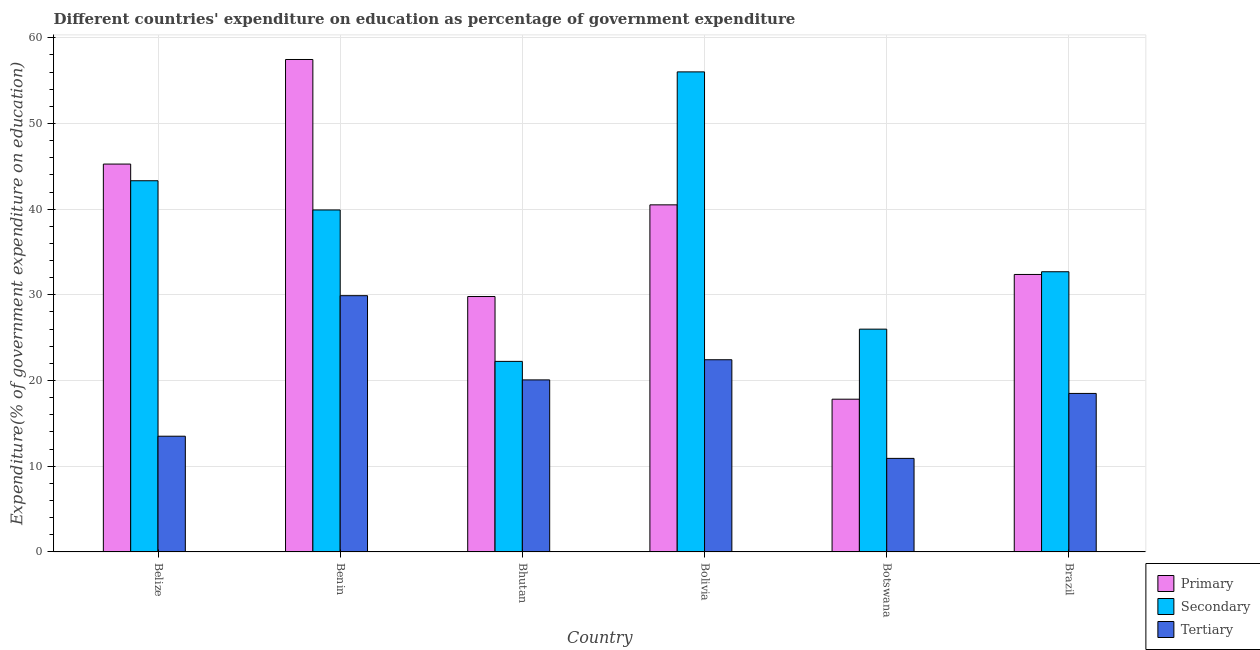How many groups of bars are there?
Offer a terse response. 6. Are the number of bars per tick equal to the number of legend labels?
Offer a terse response. Yes. Are the number of bars on each tick of the X-axis equal?
Your response must be concise. Yes. How many bars are there on the 6th tick from the left?
Ensure brevity in your answer.  3. How many bars are there on the 6th tick from the right?
Your answer should be very brief. 3. What is the label of the 1st group of bars from the left?
Give a very brief answer. Belize. In how many cases, is the number of bars for a given country not equal to the number of legend labels?
Provide a succinct answer. 0. What is the expenditure on primary education in Bhutan?
Give a very brief answer. 29.8. Across all countries, what is the maximum expenditure on tertiary education?
Your response must be concise. 29.9. Across all countries, what is the minimum expenditure on secondary education?
Make the answer very short. 22.23. In which country was the expenditure on tertiary education maximum?
Offer a very short reply. Benin. In which country was the expenditure on secondary education minimum?
Your answer should be very brief. Bhutan. What is the total expenditure on primary education in the graph?
Provide a short and direct response. 223.23. What is the difference between the expenditure on primary education in Bhutan and that in Bolivia?
Give a very brief answer. -10.7. What is the difference between the expenditure on primary education in Brazil and the expenditure on tertiary education in Botswana?
Your response must be concise. 21.46. What is the average expenditure on tertiary education per country?
Make the answer very short. 19.22. What is the difference between the expenditure on primary education and expenditure on secondary education in Belize?
Your response must be concise. 1.95. In how many countries, is the expenditure on secondary education greater than 2 %?
Give a very brief answer. 6. What is the ratio of the expenditure on tertiary education in Belize to that in Benin?
Keep it short and to the point. 0.45. Is the difference between the expenditure on tertiary education in Benin and Bolivia greater than the difference between the expenditure on secondary education in Benin and Bolivia?
Keep it short and to the point. Yes. What is the difference between the highest and the second highest expenditure on primary education?
Give a very brief answer. 12.2. What is the difference between the highest and the lowest expenditure on tertiary education?
Your answer should be compact. 18.99. In how many countries, is the expenditure on tertiary education greater than the average expenditure on tertiary education taken over all countries?
Provide a short and direct response. 3. What does the 2nd bar from the left in Bolivia represents?
Ensure brevity in your answer.  Secondary. What does the 1st bar from the right in Bolivia represents?
Offer a terse response. Tertiary. Is it the case that in every country, the sum of the expenditure on primary education and expenditure on secondary education is greater than the expenditure on tertiary education?
Ensure brevity in your answer.  Yes. How many bars are there?
Ensure brevity in your answer.  18. Are all the bars in the graph horizontal?
Offer a very short reply. No. What is the difference between two consecutive major ticks on the Y-axis?
Ensure brevity in your answer.  10. Does the graph contain grids?
Your response must be concise. Yes. How many legend labels are there?
Keep it short and to the point. 3. What is the title of the graph?
Make the answer very short. Different countries' expenditure on education as percentage of government expenditure. Does "Ages 20-50" appear as one of the legend labels in the graph?
Keep it short and to the point. No. What is the label or title of the X-axis?
Provide a short and direct response. Country. What is the label or title of the Y-axis?
Your answer should be compact. Expenditure(% of government expenditure on education). What is the Expenditure(% of government expenditure on education) of Primary in Belize?
Give a very brief answer. 45.26. What is the Expenditure(% of government expenditure on education) of Secondary in Belize?
Ensure brevity in your answer.  43.32. What is the Expenditure(% of government expenditure on education) of Tertiary in Belize?
Your answer should be very brief. 13.5. What is the Expenditure(% of government expenditure on education) in Primary in Benin?
Keep it short and to the point. 57.47. What is the Expenditure(% of government expenditure on education) in Secondary in Benin?
Keep it short and to the point. 39.91. What is the Expenditure(% of government expenditure on education) in Tertiary in Benin?
Your answer should be compact. 29.9. What is the Expenditure(% of government expenditure on education) of Primary in Bhutan?
Offer a very short reply. 29.8. What is the Expenditure(% of government expenditure on education) of Secondary in Bhutan?
Your answer should be compact. 22.23. What is the Expenditure(% of government expenditure on education) in Tertiary in Bhutan?
Keep it short and to the point. 20.07. What is the Expenditure(% of government expenditure on education) in Primary in Bolivia?
Give a very brief answer. 40.5. What is the Expenditure(% of government expenditure on education) of Secondary in Bolivia?
Keep it short and to the point. 56.02. What is the Expenditure(% of government expenditure on education) of Tertiary in Bolivia?
Make the answer very short. 22.43. What is the Expenditure(% of government expenditure on education) of Primary in Botswana?
Keep it short and to the point. 17.82. What is the Expenditure(% of government expenditure on education) of Secondary in Botswana?
Offer a very short reply. 26. What is the Expenditure(% of government expenditure on education) in Tertiary in Botswana?
Provide a succinct answer. 10.91. What is the Expenditure(% of government expenditure on education) in Primary in Brazil?
Offer a very short reply. 32.38. What is the Expenditure(% of government expenditure on education) of Secondary in Brazil?
Your response must be concise. 32.7. What is the Expenditure(% of government expenditure on education) in Tertiary in Brazil?
Offer a very short reply. 18.5. Across all countries, what is the maximum Expenditure(% of government expenditure on education) of Primary?
Ensure brevity in your answer.  57.47. Across all countries, what is the maximum Expenditure(% of government expenditure on education) in Secondary?
Offer a terse response. 56.02. Across all countries, what is the maximum Expenditure(% of government expenditure on education) of Tertiary?
Keep it short and to the point. 29.9. Across all countries, what is the minimum Expenditure(% of government expenditure on education) of Primary?
Offer a terse response. 17.82. Across all countries, what is the minimum Expenditure(% of government expenditure on education) of Secondary?
Keep it short and to the point. 22.23. Across all countries, what is the minimum Expenditure(% of government expenditure on education) in Tertiary?
Make the answer very short. 10.91. What is the total Expenditure(% of government expenditure on education) in Primary in the graph?
Provide a succinct answer. 223.23. What is the total Expenditure(% of government expenditure on education) of Secondary in the graph?
Your answer should be very brief. 220.17. What is the total Expenditure(% of government expenditure on education) in Tertiary in the graph?
Provide a succinct answer. 115.31. What is the difference between the Expenditure(% of government expenditure on education) in Primary in Belize and that in Benin?
Keep it short and to the point. -12.2. What is the difference between the Expenditure(% of government expenditure on education) in Secondary in Belize and that in Benin?
Offer a terse response. 3.41. What is the difference between the Expenditure(% of government expenditure on education) of Tertiary in Belize and that in Benin?
Give a very brief answer. -16.4. What is the difference between the Expenditure(% of government expenditure on education) in Primary in Belize and that in Bhutan?
Your answer should be compact. 15.46. What is the difference between the Expenditure(% of government expenditure on education) in Secondary in Belize and that in Bhutan?
Provide a short and direct response. 21.08. What is the difference between the Expenditure(% of government expenditure on education) in Tertiary in Belize and that in Bhutan?
Give a very brief answer. -6.57. What is the difference between the Expenditure(% of government expenditure on education) in Primary in Belize and that in Bolivia?
Your answer should be compact. 4.76. What is the difference between the Expenditure(% of government expenditure on education) in Secondary in Belize and that in Bolivia?
Provide a short and direct response. -12.7. What is the difference between the Expenditure(% of government expenditure on education) of Tertiary in Belize and that in Bolivia?
Make the answer very short. -8.92. What is the difference between the Expenditure(% of government expenditure on education) in Primary in Belize and that in Botswana?
Your response must be concise. 27.44. What is the difference between the Expenditure(% of government expenditure on education) of Secondary in Belize and that in Botswana?
Offer a very short reply. 17.32. What is the difference between the Expenditure(% of government expenditure on education) in Tertiary in Belize and that in Botswana?
Provide a short and direct response. 2.59. What is the difference between the Expenditure(% of government expenditure on education) in Primary in Belize and that in Brazil?
Give a very brief answer. 12.88. What is the difference between the Expenditure(% of government expenditure on education) of Secondary in Belize and that in Brazil?
Your answer should be very brief. 10.62. What is the difference between the Expenditure(% of government expenditure on education) of Tertiary in Belize and that in Brazil?
Offer a terse response. -4.99. What is the difference between the Expenditure(% of government expenditure on education) of Primary in Benin and that in Bhutan?
Your answer should be compact. 27.66. What is the difference between the Expenditure(% of government expenditure on education) in Secondary in Benin and that in Bhutan?
Keep it short and to the point. 17.67. What is the difference between the Expenditure(% of government expenditure on education) of Tertiary in Benin and that in Bhutan?
Ensure brevity in your answer.  9.83. What is the difference between the Expenditure(% of government expenditure on education) of Primary in Benin and that in Bolivia?
Make the answer very short. 16.96. What is the difference between the Expenditure(% of government expenditure on education) in Secondary in Benin and that in Bolivia?
Make the answer very short. -16.11. What is the difference between the Expenditure(% of government expenditure on education) of Tertiary in Benin and that in Bolivia?
Give a very brief answer. 7.48. What is the difference between the Expenditure(% of government expenditure on education) in Primary in Benin and that in Botswana?
Provide a short and direct response. 39.64. What is the difference between the Expenditure(% of government expenditure on education) of Secondary in Benin and that in Botswana?
Provide a short and direct response. 13.91. What is the difference between the Expenditure(% of government expenditure on education) in Tertiary in Benin and that in Botswana?
Provide a succinct answer. 18.99. What is the difference between the Expenditure(% of government expenditure on education) in Primary in Benin and that in Brazil?
Ensure brevity in your answer.  25.09. What is the difference between the Expenditure(% of government expenditure on education) of Secondary in Benin and that in Brazil?
Keep it short and to the point. 7.21. What is the difference between the Expenditure(% of government expenditure on education) in Tertiary in Benin and that in Brazil?
Provide a short and direct response. 11.41. What is the difference between the Expenditure(% of government expenditure on education) of Primary in Bhutan and that in Bolivia?
Ensure brevity in your answer.  -10.7. What is the difference between the Expenditure(% of government expenditure on education) of Secondary in Bhutan and that in Bolivia?
Provide a short and direct response. -33.79. What is the difference between the Expenditure(% of government expenditure on education) in Tertiary in Bhutan and that in Bolivia?
Ensure brevity in your answer.  -2.35. What is the difference between the Expenditure(% of government expenditure on education) of Primary in Bhutan and that in Botswana?
Ensure brevity in your answer.  11.98. What is the difference between the Expenditure(% of government expenditure on education) in Secondary in Bhutan and that in Botswana?
Your answer should be compact. -3.76. What is the difference between the Expenditure(% of government expenditure on education) in Tertiary in Bhutan and that in Botswana?
Give a very brief answer. 9.16. What is the difference between the Expenditure(% of government expenditure on education) of Primary in Bhutan and that in Brazil?
Offer a very short reply. -2.57. What is the difference between the Expenditure(% of government expenditure on education) of Secondary in Bhutan and that in Brazil?
Offer a very short reply. -10.46. What is the difference between the Expenditure(% of government expenditure on education) in Tertiary in Bhutan and that in Brazil?
Provide a short and direct response. 1.58. What is the difference between the Expenditure(% of government expenditure on education) in Primary in Bolivia and that in Botswana?
Your response must be concise. 22.68. What is the difference between the Expenditure(% of government expenditure on education) in Secondary in Bolivia and that in Botswana?
Your answer should be compact. 30.02. What is the difference between the Expenditure(% of government expenditure on education) of Tertiary in Bolivia and that in Botswana?
Offer a terse response. 11.51. What is the difference between the Expenditure(% of government expenditure on education) of Primary in Bolivia and that in Brazil?
Provide a short and direct response. 8.12. What is the difference between the Expenditure(% of government expenditure on education) of Secondary in Bolivia and that in Brazil?
Give a very brief answer. 23.32. What is the difference between the Expenditure(% of government expenditure on education) of Tertiary in Bolivia and that in Brazil?
Your response must be concise. 3.93. What is the difference between the Expenditure(% of government expenditure on education) of Primary in Botswana and that in Brazil?
Offer a terse response. -14.56. What is the difference between the Expenditure(% of government expenditure on education) in Secondary in Botswana and that in Brazil?
Give a very brief answer. -6.7. What is the difference between the Expenditure(% of government expenditure on education) of Tertiary in Botswana and that in Brazil?
Offer a terse response. -7.58. What is the difference between the Expenditure(% of government expenditure on education) of Primary in Belize and the Expenditure(% of government expenditure on education) of Secondary in Benin?
Ensure brevity in your answer.  5.35. What is the difference between the Expenditure(% of government expenditure on education) in Primary in Belize and the Expenditure(% of government expenditure on education) in Tertiary in Benin?
Provide a short and direct response. 15.36. What is the difference between the Expenditure(% of government expenditure on education) in Secondary in Belize and the Expenditure(% of government expenditure on education) in Tertiary in Benin?
Keep it short and to the point. 13.41. What is the difference between the Expenditure(% of government expenditure on education) of Primary in Belize and the Expenditure(% of government expenditure on education) of Secondary in Bhutan?
Ensure brevity in your answer.  23.03. What is the difference between the Expenditure(% of government expenditure on education) of Primary in Belize and the Expenditure(% of government expenditure on education) of Tertiary in Bhutan?
Your answer should be very brief. 25.19. What is the difference between the Expenditure(% of government expenditure on education) in Secondary in Belize and the Expenditure(% of government expenditure on education) in Tertiary in Bhutan?
Your response must be concise. 23.24. What is the difference between the Expenditure(% of government expenditure on education) of Primary in Belize and the Expenditure(% of government expenditure on education) of Secondary in Bolivia?
Your response must be concise. -10.76. What is the difference between the Expenditure(% of government expenditure on education) of Primary in Belize and the Expenditure(% of government expenditure on education) of Tertiary in Bolivia?
Ensure brevity in your answer.  22.84. What is the difference between the Expenditure(% of government expenditure on education) in Secondary in Belize and the Expenditure(% of government expenditure on education) in Tertiary in Bolivia?
Provide a short and direct response. 20.89. What is the difference between the Expenditure(% of government expenditure on education) in Primary in Belize and the Expenditure(% of government expenditure on education) in Secondary in Botswana?
Your answer should be very brief. 19.26. What is the difference between the Expenditure(% of government expenditure on education) in Primary in Belize and the Expenditure(% of government expenditure on education) in Tertiary in Botswana?
Keep it short and to the point. 34.35. What is the difference between the Expenditure(% of government expenditure on education) in Secondary in Belize and the Expenditure(% of government expenditure on education) in Tertiary in Botswana?
Your response must be concise. 32.4. What is the difference between the Expenditure(% of government expenditure on education) of Primary in Belize and the Expenditure(% of government expenditure on education) of Secondary in Brazil?
Make the answer very short. 12.57. What is the difference between the Expenditure(% of government expenditure on education) in Primary in Belize and the Expenditure(% of government expenditure on education) in Tertiary in Brazil?
Offer a very short reply. 26.77. What is the difference between the Expenditure(% of government expenditure on education) of Secondary in Belize and the Expenditure(% of government expenditure on education) of Tertiary in Brazil?
Your answer should be very brief. 24.82. What is the difference between the Expenditure(% of government expenditure on education) of Primary in Benin and the Expenditure(% of government expenditure on education) of Secondary in Bhutan?
Provide a short and direct response. 35.23. What is the difference between the Expenditure(% of government expenditure on education) in Primary in Benin and the Expenditure(% of government expenditure on education) in Tertiary in Bhutan?
Your answer should be compact. 37.39. What is the difference between the Expenditure(% of government expenditure on education) of Secondary in Benin and the Expenditure(% of government expenditure on education) of Tertiary in Bhutan?
Keep it short and to the point. 19.83. What is the difference between the Expenditure(% of government expenditure on education) of Primary in Benin and the Expenditure(% of government expenditure on education) of Secondary in Bolivia?
Offer a very short reply. 1.45. What is the difference between the Expenditure(% of government expenditure on education) in Primary in Benin and the Expenditure(% of government expenditure on education) in Tertiary in Bolivia?
Your answer should be compact. 35.04. What is the difference between the Expenditure(% of government expenditure on education) of Secondary in Benin and the Expenditure(% of government expenditure on education) of Tertiary in Bolivia?
Keep it short and to the point. 17.48. What is the difference between the Expenditure(% of government expenditure on education) of Primary in Benin and the Expenditure(% of government expenditure on education) of Secondary in Botswana?
Offer a very short reply. 31.47. What is the difference between the Expenditure(% of government expenditure on education) in Primary in Benin and the Expenditure(% of government expenditure on education) in Tertiary in Botswana?
Give a very brief answer. 46.55. What is the difference between the Expenditure(% of government expenditure on education) in Secondary in Benin and the Expenditure(% of government expenditure on education) in Tertiary in Botswana?
Give a very brief answer. 28.99. What is the difference between the Expenditure(% of government expenditure on education) of Primary in Benin and the Expenditure(% of government expenditure on education) of Secondary in Brazil?
Offer a very short reply. 24.77. What is the difference between the Expenditure(% of government expenditure on education) of Primary in Benin and the Expenditure(% of government expenditure on education) of Tertiary in Brazil?
Offer a very short reply. 38.97. What is the difference between the Expenditure(% of government expenditure on education) of Secondary in Benin and the Expenditure(% of government expenditure on education) of Tertiary in Brazil?
Your response must be concise. 21.41. What is the difference between the Expenditure(% of government expenditure on education) of Primary in Bhutan and the Expenditure(% of government expenditure on education) of Secondary in Bolivia?
Provide a succinct answer. -26.22. What is the difference between the Expenditure(% of government expenditure on education) of Primary in Bhutan and the Expenditure(% of government expenditure on education) of Tertiary in Bolivia?
Offer a terse response. 7.38. What is the difference between the Expenditure(% of government expenditure on education) of Secondary in Bhutan and the Expenditure(% of government expenditure on education) of Tertiary in Bolivia?
Offer a terse response. -0.19. What is the difference between the Expenditure(% of government expenditure on education) of Primary in Bhutan and the Expenditure(% of government expenditure on education) of Secondary in Botswana?
Provide a short and direct response. 3.81. What is the difference between the Expenditure(% of government expenditure on education) of Primary in Bhutan and the Expenditure(% of government expenditure on education) of Tertiary in Botswana?
Make the answer very short. 18.89. What is the difference between the Expenditure(% of government expenditure on education) of Secondary in Bhutan and the Expenditure(% of government expenditure on education) of Tertiary in Botswana?
Ensure brevity in your answer.  11.32. What is the difference between the Expenditure(% of government expenditure on education) in Primary in Bhutan and the Expenditure(% of government expenditure on education) in Secondary in Brazil?
Offer a very short reply. -2.89. What is the difference between the Expenditure(% of government expenditure on education) of Primary in Bhutan and the Expenditure(% of government expenditure on education) of Tertiary in Brazil?
Provide a succinct answer. 11.31. What is the difference between the Expenditure(% of government expenditure on education) of Secondary in Bhutan and the Expenditure(% of government expenditure on education) of Tertiary in Brazil?
Give a very brief answer. 3.74. What is the difference between the Expenditure(% of government expenditure on education) in Primary in Bolivia and the Expenditure(% of government expenditure on education) in Secondary in Botswana?
Keep it short and to the point. 14.51. What is the difference between the Expenditure(% of government expenditure on education) in Primary in Bolivia and the Expenditure(% of government expenditure on education) in Tertiary in Botswana?
Offer a terse response. 29.59. What is the difference between the Expenditure(% of government expenditure on education) of Secondary in Bolivia and the Expenditure(% of government expenditure on education) of Tertiary in Botswana?
Provide a short and direct response. 45.11. What is the difference between the Expenditure(% of government expenditure on education) of Primary in Bolivia and the Expenditure(% of government expenditure on education) of Secondary in Brazil?
Your answer should be very brief. 7.81. What is the difference between the Expenditure(% of government expenditure on education) of Primary in Bolivia and the Expenditure(% of government expenditure on education) of Tertiary in Brazil?
Your response must be concise. 22.01. What is the difference between the Expenditure(% of government expenditure on education) of Secondary in Bolivia and the Expenditure(% of government expenditure on education) of Tertiary in Brazil?
Provide a succinct answer. 37.52. What is the difference between the Expenditure(% of government expenditure on education) in Primary in Botswana and the Expenditure(% of government expenditure on education) in Secondary in Brazil?
Offer a very short reply. -14.87. What is the difference between the Expenditure(% of government expenditure on education) of Primary in Botswana and the Expenditure(% of government expenditure on education) of Tertiary in Brazil?
Offer a very short reply. -0.67. What is the difference between the Expenditure(% of government expenditure on education) in Secondary in Botswana and the Expenditure(% of government expenditure on education) in Tertiary in Brazil?
Provide a short and direct response. 7.5. What is the average Expenditure(% of government expenditure on education) in Primary per country?
Your answer should be very brief. 37.21. What is the average Expenditure(% of government expenditure on education) of Secondary per country?
Your answer should be compact. 36.69. What is the average Expenditure(% of government expenditure on education) in Tertiary per country?
Ensure brevity in your answer.  19.22. What is the difference between the Expenditure(% of government expenditure on education) of Primary and Expenditure(% of government expenditure on education) of Secondary in Belize?
Give a very brief answer. 1.95. What is the difference between the Expenditure(% of government expenditure on education) in Primary and Expenditure(% of government expenditure on education) in Tertiary in Belize?
Your answer should be compact. 31.76. What is the difference between the Expenditure(% of government expenditure on education) in Secondary and Expenditure(% of government expenditure on education) in Tertiary in Belize?
Provide a succinct answer. 29.81. What is the difference between the Expenditure(% of government expenditure on education) in Primary and Expenditure(% of government expenditure on education) in Secondary in Benin?
Give a very brief answer. 17.56. What is the difference between the Expenditure(% of government expenditure on education) in Primary and Expenditure(% of government expenditure on education) in Tertiary in Benin?
Your response must be concise. 27.56. What is the difference between the Expenditure(% of government expenditure on education) of Secondary and Expenditure(% of government expenditure on education) of Tertiary in Benin?
Provide a short and direct response. 10. What is the difference between the Expenditure(% of government expenditure on education) in Primary and Expenditure(% of government expenditure on education) in Secondary in Bhutan?
Offer a very short reply. 7.57. What is the difference between the Expenditure(% of government expenditure on education) in Primary and Expenditure(% of government expenditure on education) in Tertiary in Bhutan?
Your response must be concise. 9.73. What is the difference between the Expenditure(% of government expenditure on education) in Secondary and Expenditure(% of government expenditure on education) in Tertiary in Bhutan?
Give a very brief answer. 2.16. What is the difference between the Expenditure(% of government expenditure on education) in Primary and Expenditure(% of government expenditure on education) in Secondary in Bolivia?
Your answer should be compact. -15.52. What is the difference between the Expenditure(% of government expenditure on education) of Primary and Expenditure(% of government expenditure on education) of Tertiary in Bolivia?
Offer a very short reply. 18.08. What is the difference between the Expenditure(% of government expenditure on education) in Secondary and Expenditure(% of government expenditure on education) in Tertiary in Bolivia?
Your answer should be very brief. 33.59. What is the difference between the Expenditure(% of government expenditure on education) of Primary and Expenditure(% of government expenditure on education) of Secondary in Botswana?
Keep it short and to the point. -8.17. What is the difference between the Expenditure(% of government expenditure on education) of Primary and Expenditure(% of government expenditure on education) of Tertiary in Botswana?
Provide a succinct answer. 6.91. What is the difference between the Expenditure(% of government expenditure on education) in Secondary and Expenditure(% of government expenditure on education) in Tertiary in Botswana?
Give a very brief answer. 15.08. What is the difference between the Expenditure(% of government expenditure on education) of Primary and Expenditure(% of government expenditure on education) of Secondary in Brazil?
Offer a very short reply. -0.32. What is the difference between the Expenditure(% of government expenditure on education) in Primary and Expenditure(% of government expenditure on education) in Tertiary in Brazil?
Ensure brevity in your answer.  13.88. What is the difference between the Expenditure(% of government expenditure on education) in Secondary and Expenditure(% of government expenditure on education) in Tertiary in Brazil?
Your answer should be very brief. 14.2. What is the ratio of the Expenditure(% of government expenditure on education) in Primary in Belize to that in Benin?
Give a very brief answer. 0.79. What is the ratio of the Expenditure(% of government expenditure on education) in Secondary in Belize to that in Benin?
Offer a very short reply. 1.09. What is the ratio of the Expenditure(% of government expenditure on education) in Tertiary in Belize to that in Benin?
Ensure brevity in your answer.  0.45. What is the ratio of the Expenditure(% of government expenditure on education) in Primary in Belize to that in Bhutan?
Your answer should be very brief. 1.52. What is the ratio of the Expenditure(% of government expenditure on education) of Secondary in Belize to that in Bhutan?
Your answer should be very brief. 1.95. What is the ratio of the Expenditure(% of government expenditure on education) of Tertiary in Belize to that in Bhutan?
Your response must be concise. 0.67. What is the ratio of the Expenditure(% of government expenditure on education) of Primary in Belize to that in Bolivia?
Give a very brief answer. 1.12. What is the ratio of the Expenditure(% of government expenditure on education) of Secondary in Belize to that in Bolivia?
Keep it short and to the point. 0.77. What is the ratio of the Expenditure(% of government expenditure on education) in Tertiary in Belize to that in Bolivia?
Your answer should be very brief. 0.6. What is the ratio of the Expenditure(% of government expenditure on education) in Primary in Belize to that in Botswana?
Your answer should be compact. 2.54. What is the ratio of the Expenditure(% of government expenditure on education) in Secondary in Belize to that in Botswana?
Provide a short and direct response. 1.67. What is the ratio of the Expenditure(% of government expenditure on education) in Tertiary in Belize to that in Botswana?
Your response must be concise. 1.24. What is the ratio of the Expenditure(% of government expenditure on education) of Primary in Belize to that in Brazil?
Keep it short and to the point. 1.4. What is the ratio of the Expenditure(% of government expenditure on education) in Secondary in Belize to that in Brazil?
Your response must be concise. 1.32. What is the ratio of the Expenditure(% of government expenditure on education) of Tertiary in Belize to that in Brazil?
Offer a terse response. 0.73. What is the ratio of the Expenditure(% of government expenditure on education) in Primary in Benin to that in Bhutan?
Provide a succinct answer. 1.93. What is the ratio of the Expenditure(% of government expenditure on education) of Secondary in Benin to that in Bhutan?
Offer a very short reply. 1.79. What is the ratio of the Expenditure(% of government expenditure on education) in Tertiary in Benin to that in Bhutan?
Provide a short and direct response. 1.49. What is the ratio of the Expenditure(% of government expenditure on education) of Primary in Benin to that in Bolivia?
Your answer should be compact. 1.42. What is the ratio of the Expenditure(% of government expenditure on education) in Secondary in Benin to that in Bolivia?
Your response must be concise. 0.71. What is the ratio of the Expenditure(% of government expenditure on education) of Tertiary in Benin to that in Bolivia?
Give a very brief answer. 1.33. What is the ratio of the Expenditure(% of government expenditure on education) in Primary in Benin to that in Botswana?
Ensure brevity in your answer.  3.22. What is the ratio of the Expenditure(% of government expenditure on education) of Secondary in Benin to that in Botswana?
Keep it short and to the point. 1.54. What is the ratio of the Expenditure(% of government expenditure on education) of Tertiary in Benin to that in Botswana?
Your answer should be very brief. 2.74. What is the ratio of the Expenditure(% of government expenditure on education) in Primary in Benin to that in Brazil?
Your answer should be very brief. 1.77. What is the ratio of the Expenditure(% of government expenditure on education) of Secondary in Benin to that in Brazil?
Ensure brevity in your answer.  1.22. What is the ratio of the Expenditure(% of government expenditure on education) of Tertiary in Benin to that in Brazil?
Give a very brief answer. 1.62. What is the ratio of the Expenditure(% of government expenditure on education) in Primary in Bhutan to that in Bolivia?
Your response must be concise. 0.74. What is the ratio of the Expenditure(% of government expenditure on education) of Secondary in Bhutan to that in Bolivia?
Offer a terse response. 0.4. What is the ratio of the Expenditure(% of government expenditure on education) of Tertiary in Bhutan to that in Bolivia?
Keep it short and to the point. 0.9. What is the ratio of the Expenditure(% of government expenditure on education) of Primary in Bhutan to that in Botswana?
Provide a short and direct response. 1.67. What is the ratio of the Expenditure(% of government expenditure on education) in Secondary in Bhutan to that in Botswana?
Provide a succinct answer. 0.86. What is the ratio of the Expenditure(% of government expenditure on education) of Tertiary in Bhutan to that in Botswana?
Your response must be concise. 1.84. What is the ratio of the Expenditure(% of government expenditure on education) of Primary in Bhutan to that in Brazil?
Your response must be concise. 0.92. What is the ratio of the Expenditure(% of government expenditure on education) of Secondary in Bhutan to that in Brazil?
Your answer should be compact. 0.68. What is the ratio of the Expenditure(% of government expenditure on education) of Tertiary in Bhutan to that in Brazil?
Ensure brevity in your answer.  1.09. What is the ratio of the Expenditure(% of government expenditure on education) in Primary in Bolivia to that in Botswana?
Your answer should be compact. 2.27. What is the ratio of the Expenditure(% of government expenditure on education) in Secondary in Bolivia to that in Botswana?
Ensure brevity in your answer.  2.15. What is the ratio of the Expenditure(% of government expenditure on education) of Tertiary in Bolivia to that in Botswana?
Offer a very short reply. 2.05. What is the ratio of the Expenditure(% of government expenditure on education) of Primary in Bolivia to that in Brazil?
Offer a very short reply. 1.25. What is the ratio of the Expenditure(% of government expenditure on education) in Secondary in Bolivia to that in Brazil?
Provide a succinct answer. 1.71. What is the ratio of the Expenditure(% of government expenditure on education) in Tertiary in Bolivia to that in Brazil?
Your response must be concise. 1.21. What is the ratio of the Expenditure(% of government expenditure on education) of Primary in Botswana to that in Brazil?
Your answer should be compact. 0.55. What is the ratio of the Expenditure(% of government expenditure on education) in Secondary in Botswana to that in Brazil?
Give a very brief answer. 0.8. What is the ratio of the Expenditure(% of government expenditure on education) in Tertiary in Botswana to that in Brazil?
Your response must be concise. 0.59. What is the difference between the highest and the second highest Expenditure(% of government expenditure on education) in Primary?
Your answer should be compact. 12.2. What is the difference between the highest and the second highest Expenditure(% of government expenditure on education) of Secondary?
Your answer should be very brief. 12.7. What is the difference between the highest and the second highest Expenditure(% of government expenditure on education) in Tertiary?
Ensure brevity in your answer.  7.48. What is the difference between the highest and the lowest Expenditure(% of government expenditure on education) of Primary?
Offer a very short reply. 39.64. What is the difference between the highest and the lowest Expenditure(% of government expenditure on education) in Secondary?
Offer a very short reply. 33.79. What is the difference between the highest and the lowest Expenditure(% of government expenditure on education) in Tertiary?
Make the answer very short. 18.99. 